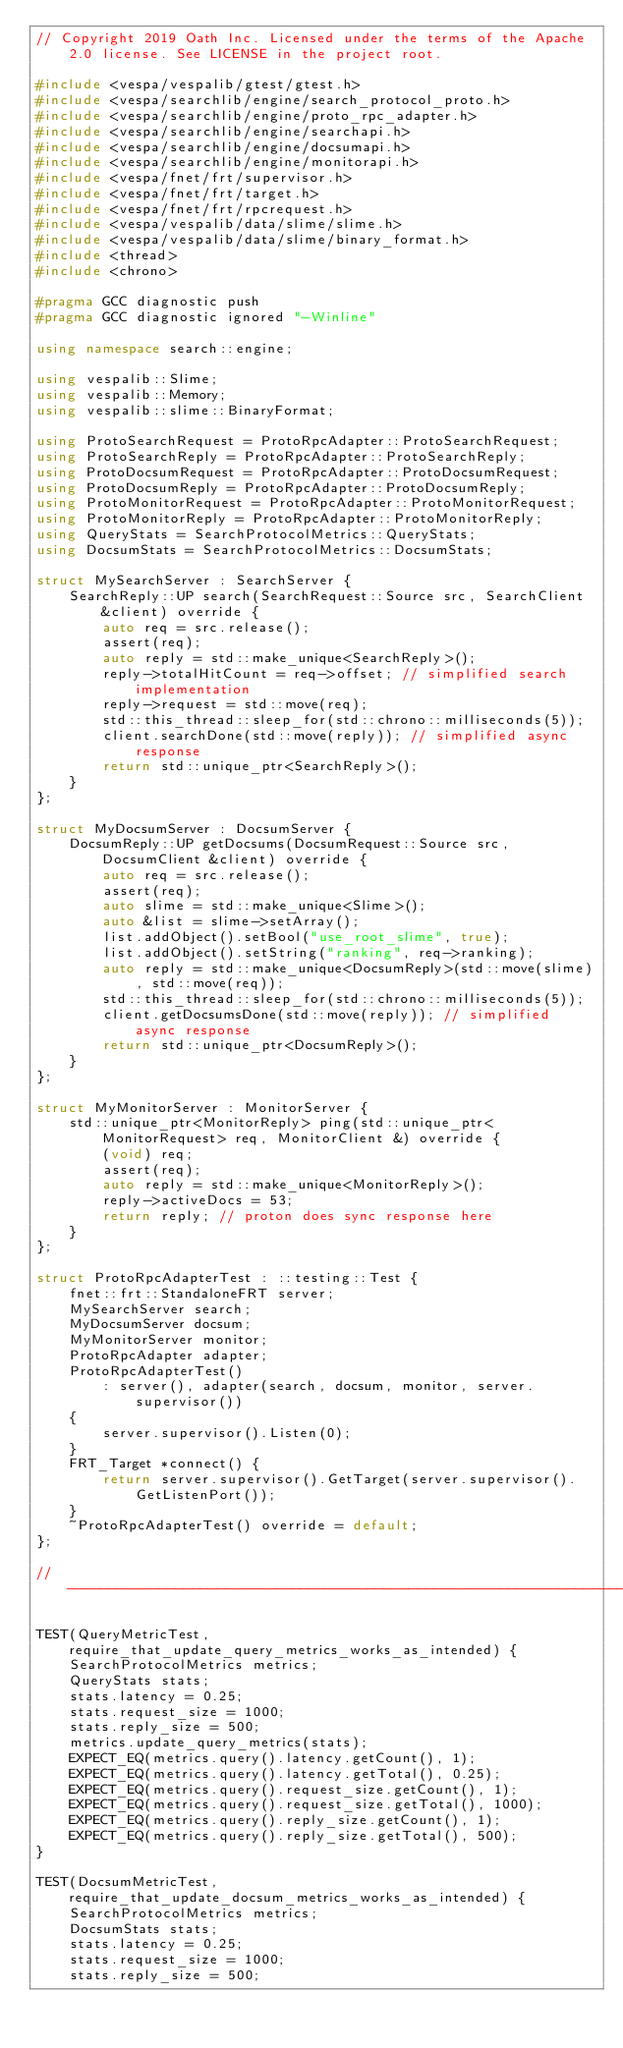Convert code to text. <code><loc_0><loc_0><loc_500><loc_500><_C++_>// Copyright 2019 Oath Inc. Licensed under the terms of the Apache 2.0 license. See LICENSE in the project root.

#include <vespa/vespalib/gtest/gtest.h>
#include <vespa/searchlib/engine/search_protocol_proto.h>
#include <vespa/searchlib/engine/proto_rpc_adapter.h>
#include <vespa/searchlib/engine/searchapi.h>
#include <vespa/searchlib/engine/docsumapi.h>
#include <vespa/searchlib/engine/monitorapi.h>
#include <vespa/fnet/frt/supervisor.h>
#include <vespa/fnet/frt/target.h>
#include <vespa/fnet/frt/rpcrequest.h>
#include <vespa/vespalib/data/slime/slime.h>
#include <vespa/vespalib/data/slime/binary_format.h>
#include <thread>
#include <chrono>

#pragma GCC diagnostic push
#pragma GCC diagnostic ignored "-Winline"

using namespace search::engine;

using vespalib::Slime;
using vespalib::Memory;
using vespalib::slime::BinaryFormat;

using ProtoSearchRequest = ProtoRpcAdapter::ProtoSearchRequest;
using ProtoSearchReply = ProtoRpcAdapter::ProtoSearchReply;
using ProtoDocsumRequest = ProtoRpcAdapter::ProtoDocsumRequest;
using ProtoDocsumReply = ProtoRpcAdapter::ProtoDocsumReply;
using ProtoMonitorRequest = ProtoRpcAdapter::ProtoMonitorRequest;
using ProtoMonitorReply = ProtoRpcAdapter::ProtoMonitorReply;
using QueryStats = SearchProtocolMetrics::QueryStats;
using DocsumStats = SearchProtocolMetrics::DocsumStats;

struct MySearchServer : SearchServer {
    SearchReply::UP search(SearchRequest::Source src, SearchClient &client) override {
        auto req = src.release();
        assert(req);
        auto reply = std::make_unique<SearchReply>();
        reply->totalHitCount = req->offset; // simplified search implementation
        reply->request = std::move(req);
        std::this_thread::sleep_for(std::chrono::milliseconds(5));
        client.searchDone(std::move(reply)); // simplified async response
        return std::unique_ptr<SearchReply>();
    }
};

struct MyDocsumServer : DocsumServer {
    DocsumReply::UP getDocsums(DocsumRequest::Source src, DocsumClient &client) override {
        auto req = src.release();
        assert(req);
        auto slime = std::make_unique<Slime>();
        auto &list = slime->setArray();
        list.addObject().setBool("use_root_slime", true);
        list.addObject().setString("ranking", req->ranking);
        auto reply = std::make_unique<DocsumReply>(std::move(slime), std::move(req));
        std::this_thread::sleep_for(std::chrono::milliseconds(5));
        client.getDocsumsDone(std::move(reply)); // simplified async response
        return std::unique_ptr<DocsumReply>();
    }
};

struct MyMonitorServer : MonitorServer {
    std::unique_ptr<MonitorReply> ping(std::unique_ptr<MonitorRequest> req, MonitorClient &) override {
        (void) req;
        assert(req);
        auto reply = std::make_unique<MonitorReply>();
        reply->activeDocs = 53;
        return reply; // proton does sync response here
    }
};

struct ProtoRpcAdapterTest : ::testing::Test {
    fnet::frt::StandaloneFRT server;
    MySearchServer search;
    MyDocsumServer docsum;
    MyMonitorServer monitor;
    ProtoRpcAdapter adapter;
    ProtoRpcAdapterTest()
        : server(), adapter(search, docsum, monitor, server.supervisor())
    {
        server.supervisor().Listen(0);
    }
    FRT_Target *connect() {
        return server.supervisor().GetTarget(server.supervisor().GetListenPort());
    }
    ~ProtoRpcAdapterTest() override = default;
};

//-----------------------------------------------------------------------------

TEST(QueryMetricTest, require_that_update_query_metrics_works_as_intended) {
    SearchProtocolMetrics metrics;
    QueryStats stats;
    stats.latency = 0.25;
    stats.request_size = 1000;
    stats.reply_size = 500;
    metrics.update_query_metrics(stats);
    EXPECT_EQ(metrics.query().latency.getCount(), 1);
    EXPECT_EQ(metrics.query().latency.getTotal(), 0.25);
    EXPECT_EQ(metrics.query().request_size.getCount(), 1);
    EXPECT_EQ(metrics.query().request_size.getTotal(), 1000);
    EXPECT_EQ(metrics.query().reply_size.getCount(), 1);
    EXPECT_EQ(metrics.query().reply_size.getTotal(), 500);
}

TEST(DocsumMetricTest, require_that_update_docsum_metrics_works_as_intended) {
    SearchProtocolMetrics metrics;
    DocsumStats stats;
    stats.latency = 0.25;
    stats.request_size = 1000;
    stats.reply_size = 500;</code> 